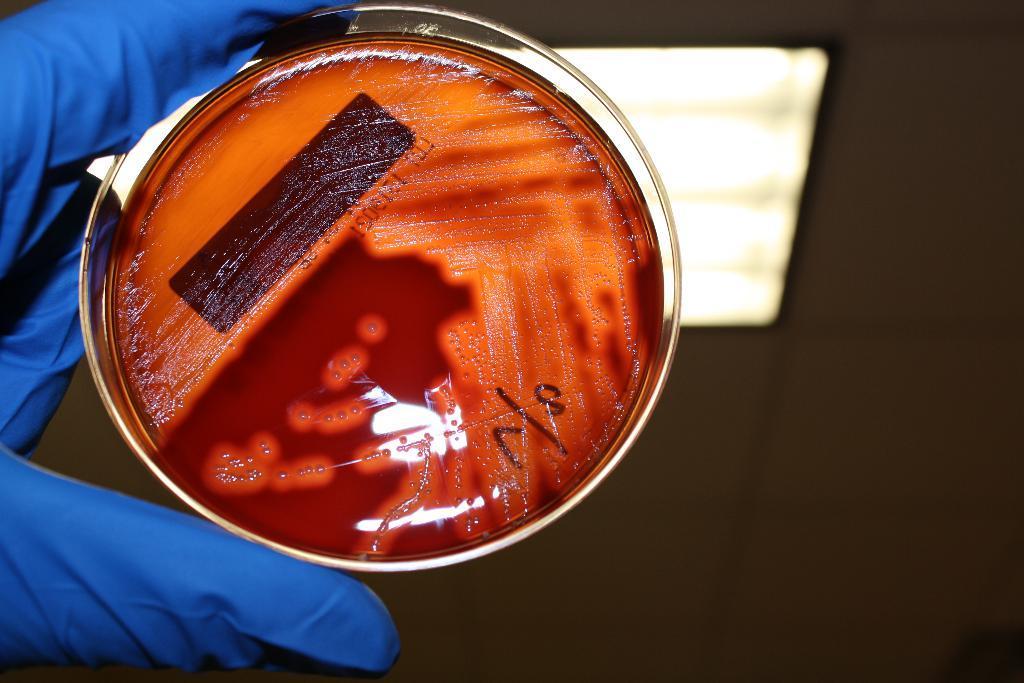Can you describe this image briefly? In this image there is a person's hand towards the left of the image, there is a glove on the person's hand, there is a bowl, there is liquid in the bowl, there is gel in the bowl, there is text, there is a light, the background of the image is dark. 